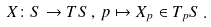Convert formula to latex. <formula><loc_0><loc_0><loc_500><loc_500>X \colon S \rightarrow T S \, , \, p \mapsto X _ { p } \in T _ { p } S \, .</formula> 